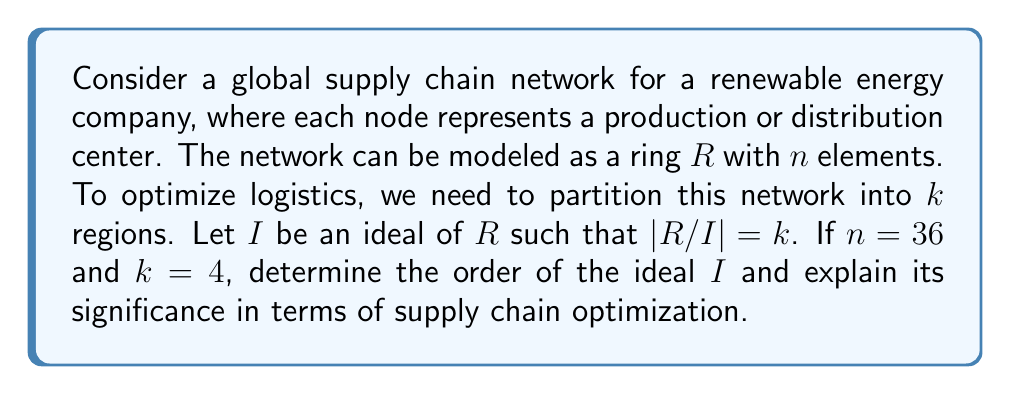What is the answer to this math problem? To solve this problem, let's break it down into steps:

1) We are given that $R$ is a ring with $n = 36$ elements, representing the total number of nodes in the supply chain network.

2) We need to partition this network into $k = 4$ regions, which corresponds to creating a quotient ring $R/I$ with 4 elements.

3) In ring theory, for a finite ring $R$ and an ideal $I$, we have the following relationship:

   $$|R| = |R/I| \cdot |I|$$

   Where $|R|$ is the order of the ring, $|R/I|$ is the order of the quotient ring, and $|I|$ is the order of the ideal.

4) Substituting the known values:

   $$36 = 4 \cdot |I|$$

5) Solving for $|I|$:

   $$|I| = 36 / 4 = 9$$

6) Therefore, the order of the ideal $I$ is 9.

In terms of supply chain optimization, this result has significant implications:

- The quotient ring $R/I$ represents the 4 main regions or clusters in the supply chain network.
- Each element of $R/I$ corresponds to a set of 9 nodes in the original network (since $|I| = 9$).
- This partitioning allows for more efficient management and coordination within each region while maintaining a global perspective.
- The ideal $I$ represents the "local" structure within each region, which can be optimized independently.
- This structure can help in balancing workload, reducing transportation costs, and improving overall efficiency in the global supply chain.
Answer: The order of the ideal $I$ is 9. 